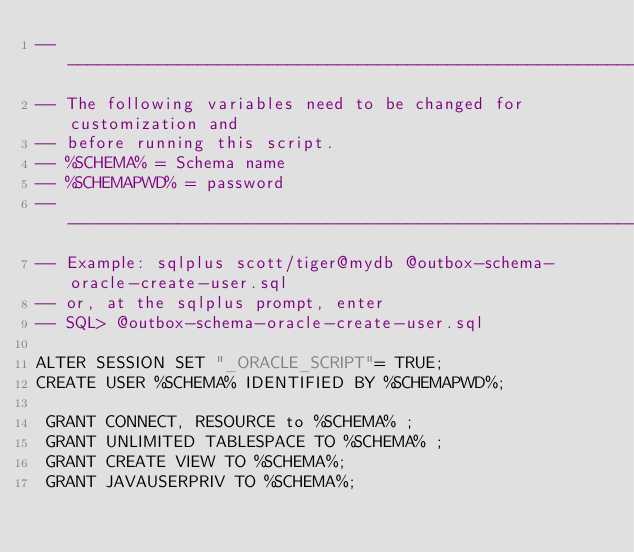<code> <loc_0><loc_0><loc_500><loc_500><_SQL_>----------------------------------------------------------------------
-- The following variables need to be changed for customization and
-- before running this script.
-- %SCHEMA% = Schema name
-- %SCHEMAPWD% = password
----------------------------------------------------------------------
-- Example: sqlplus scott/tiger@mydb @outbox-schema-oracle-create-user.sql
-- or, at the sqlplus prompt, enter
-- SQL> @outbox-schema-oracle-create-user.sql

ALTER SESSION SET "_ORACLE_SCRIPT"= TRUE;
CREATE USER %SCHEMA% IDENTIFIED BY %SCHEMAPWD%;

 GRANT CONNECT, RESOURCE to %SCHEMA% ;
 GRANT UNLIMITED TABLESPACE TO %SCHEMA% ;
 GRANT CREATE VIEW TO %SCHEMA%;
 GRANT JAVAUSERPRIV TO %SCHEMA%;

</code> 